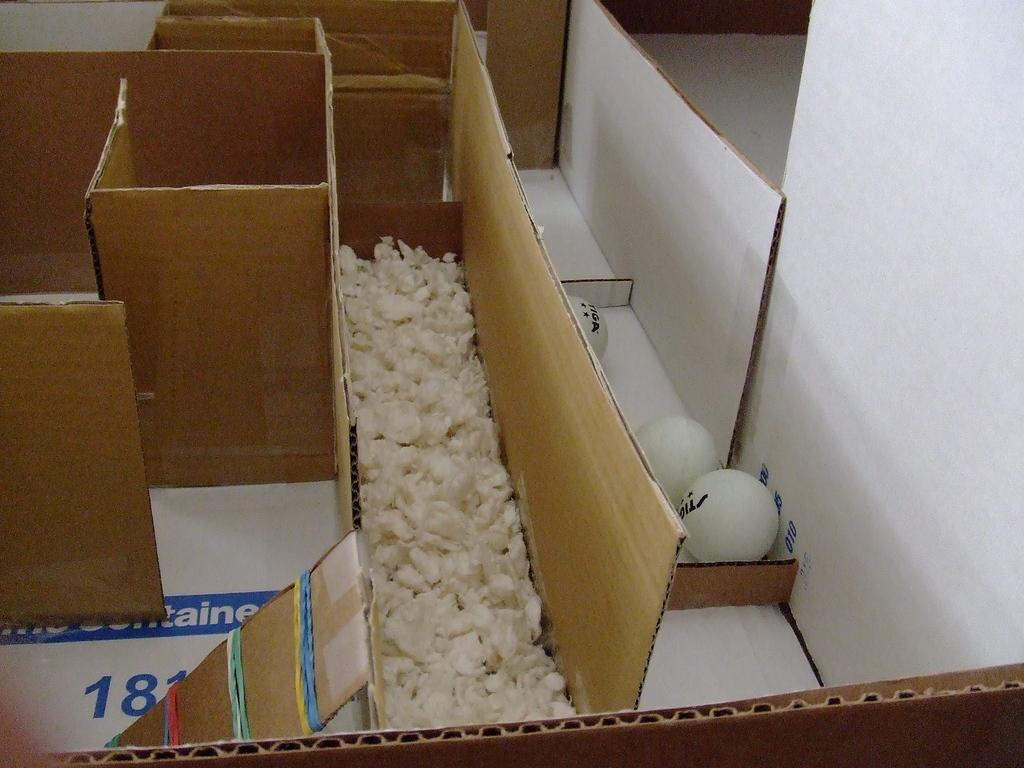<image>
Create a compact narrative representing the image presented. Three Tiga gold balls are on a strip of cardboard in what looks like a home made maze. 